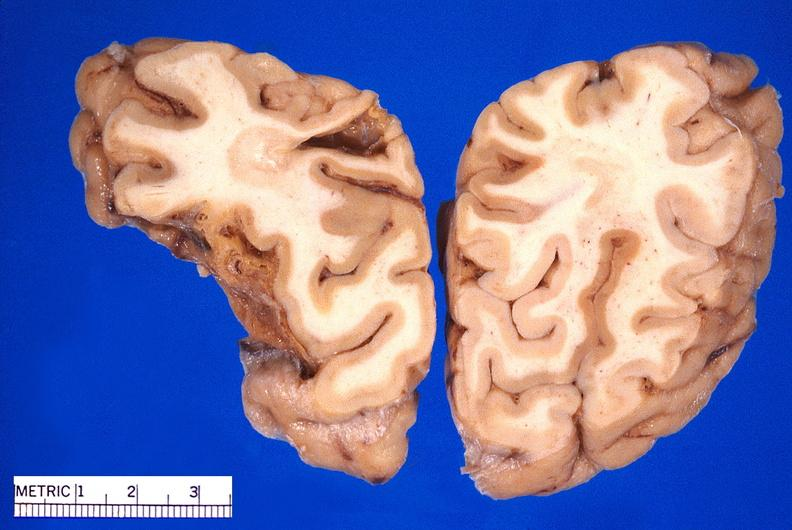what does this image show?
Answer the question using a single word or phrase. Brain 